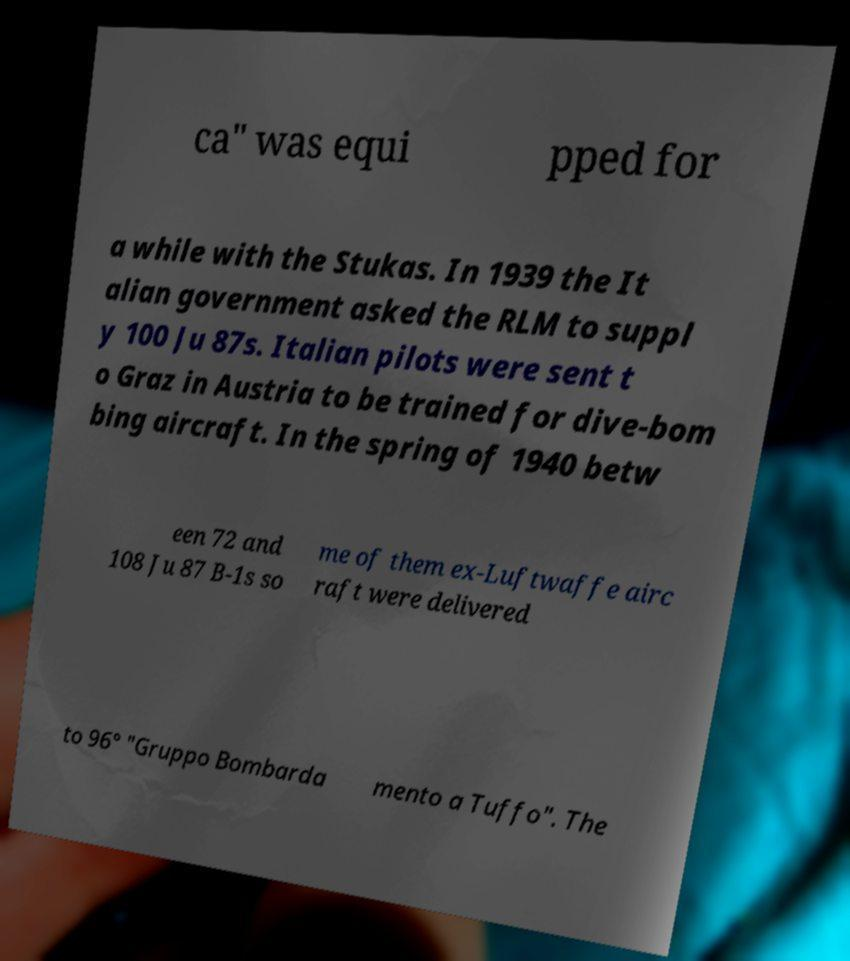Please identify and transcribe the text found in this image. ca" was equi pped for a while with the Stukas. In 1939 the It alian government asked the RLM to suppl y 100 Ju 87s. Italian pilots were sent t o Graz in Austria to be trained for dive-bom bing aircraft. In the spring of 1940 betw een 72 and 108 Ju 87 B-1s so me of them ex-Luftwaffe airc raft were delivered to 96° "Gruppo Bombarda mento a Tuffo". The 